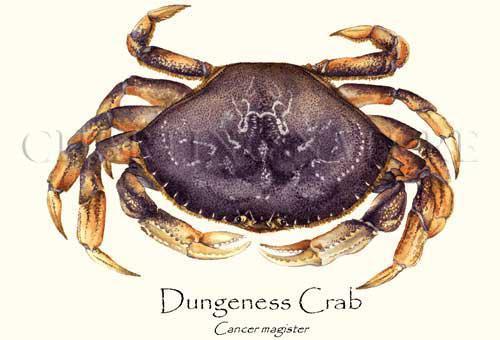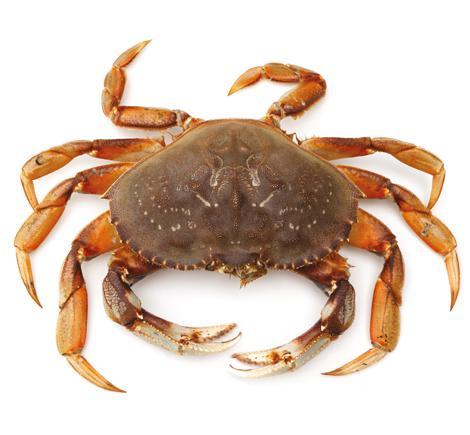The first image is the image on the left, the second image is the image on the right. Considering the images on both sides, is "The left and right image contains the same number of crabs facing the same direction." valid? Answer yes or no. Yes. The first image is the image on the left, the second image is the image on the right. For the images shown, is this caption "Both crabs are facing the same direction." true? Answer yes or no. Yes. 